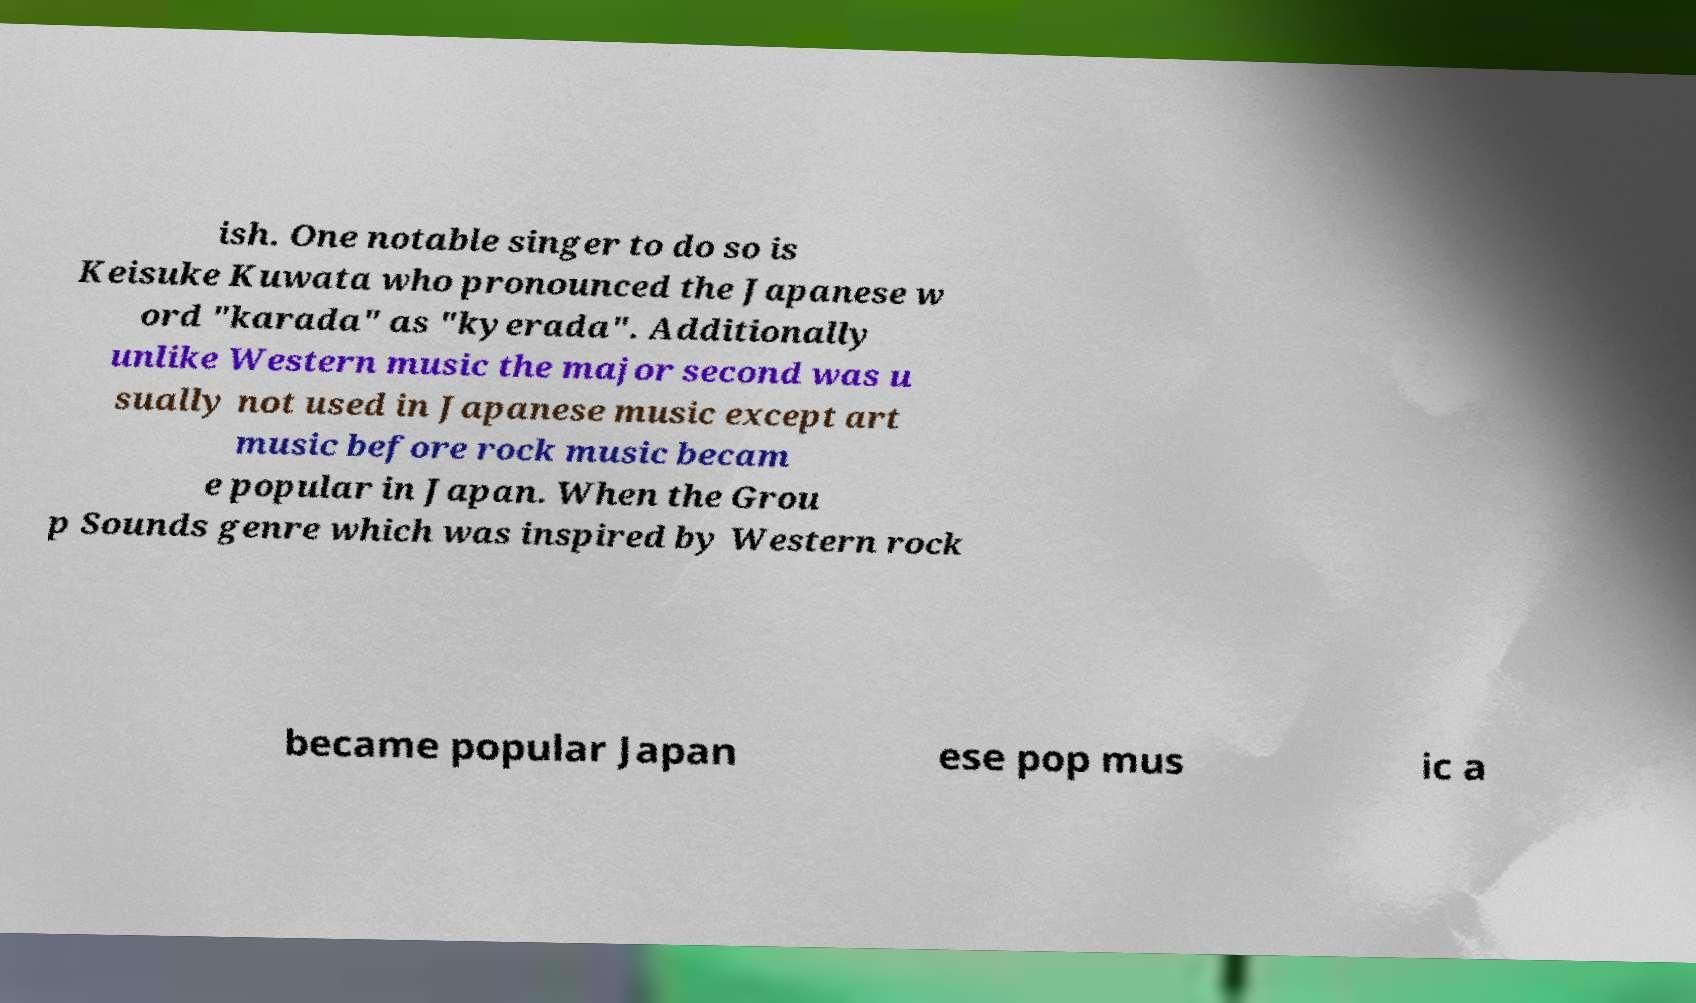Can you read and provide the text displayed in the image?This photo seems to have some interesting text. Can you extract and type it out for me? ish. One notable singer to do so is Keisuke Kuwata who pronounced the Japanese w ord "karada" as "kyerada". Additionally unlike Western music the major second was u sually not used in Japanese music except art music before rock music becam e popular in Japan. When the Grou p Sounds genre which was inspired by Western rock became popular Japan ese pop mus ic a 